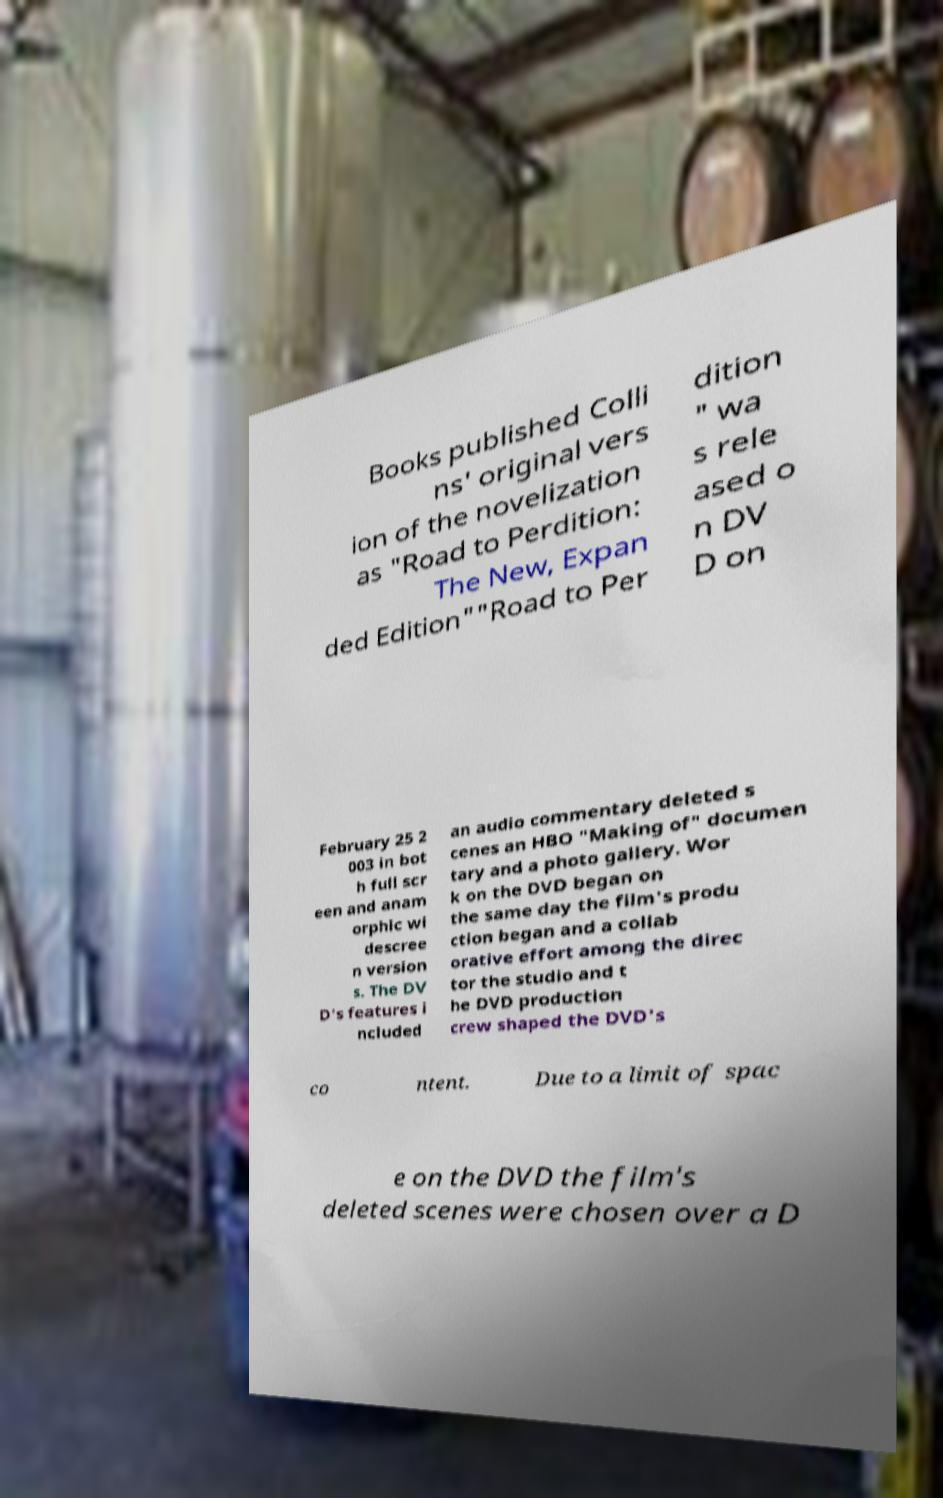For documentation purposes, I need the text within this image transcribed. Could you provide that? Books published Colli ns' original vers ion of the novelization as "Road to Perdition: The New, Expan ded Edition""Road to Per dition " wa s rele ased o n DV D on February 25 2 003 in bot h full scr een and anam orphic wi descree n version s. The DV D's features i ncluded an audio commentary deleted s cenes an HBO "Making of" documen tary and a photo gallery. Wor k on the DVD began on the same day the film's produ ction began and a collab orative effort among the direc tor the studio and t he DVD production crew shaped the DVD's co ntent. Due to a limit of spac e on the DVD the film's deleted scenes were chosen over a D 